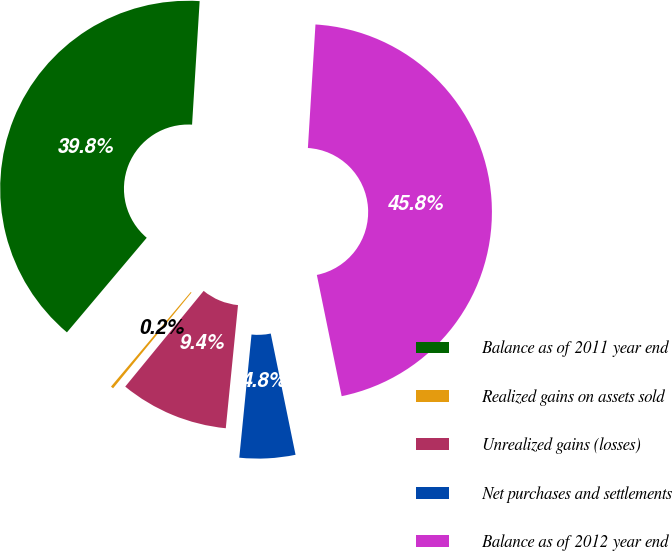<chart> <loc_0><loc_0><loc_500><loc_500><pie_chart><fcel>Balance as of 2011 year end<fcel>Realized gains on assets sold<fcel>Unrealized gains (losses)<fcel>Net purchases and settlements<fcel>Balance as of 2012 year end<nl><fcel>39.82%<fcel>0.23%<fcel>9.35%<fcel>4.79%<fcel>45.81%<nl></chart> 